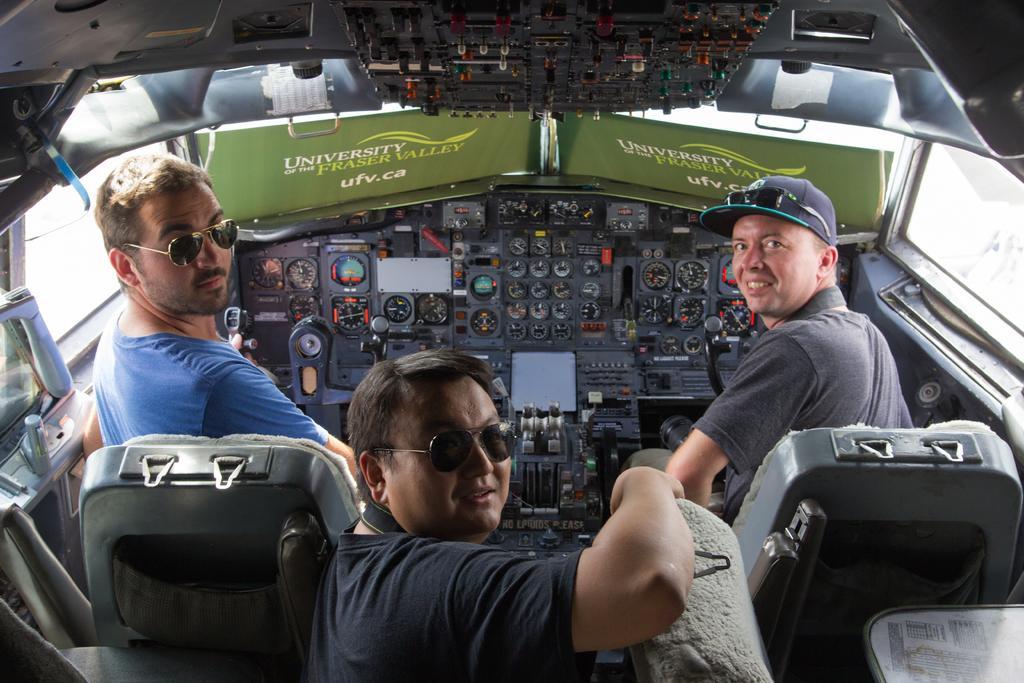How would you summarize this image in a sentence or two? In this picture, we see three men are sitting on the seats. They are looking at the camera. In front of them, we see the inner parts of the vehicle. This picture is clicked inside the vehicle. In front of them, we see green color boards with some text written on it. 